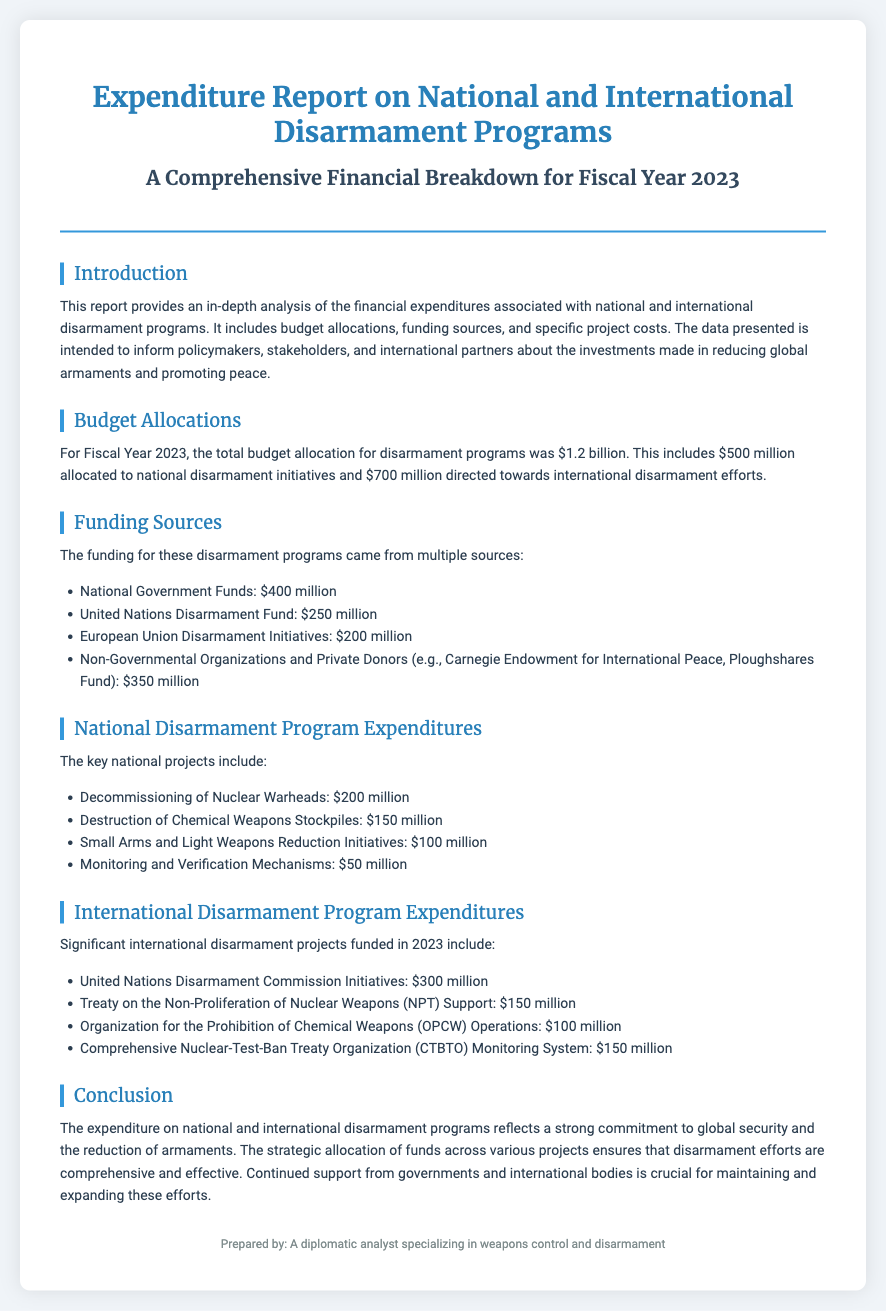What is the total budget allocation for disarmament programs? The total budget allocation for Fiscal Year 2023 is explicitly stated in the document as $1.2 billion.
Answer: $1.2 billion How much was allocated to national disarmament initiatives? The document specifies that $500 million was allocated to national disarmament initiatives.
Answer: $500 million What is one source of funding mentioned in the document? The document lists multiple funding sources, one of which is the National Government Funds.
Answer: National Government Funds What is the expenditure for the destruction of chemical weapons stockpiles? The specific project cost for the destruction of chemical weapons stockpiles is provided in the document as $150 million.
Answer: $150 million How much is allocated to the United Nations Disarmament Commission Initiatives? The expenditure for the United Nations Disarmament Commission Initiatives is detailed in the document as $300 million.
Answer: $300 million Which international treaty received $150 million for support? The document mentions that the Treaty on the Non-Proliferation of Nuclear Weapons received $150 million for support.
Answer: Treaty on the Non-Proliferation of Nuclear Weapons What is the focus of the expenditure report? The primary focus of the expenditure report is the financial expenditures associated with disarmament programs.
Answer: Financial expenditures associated with disarmament programs How much was spent on monitoring and verification mechanisms? The document states that $50 million was spent on monitoring and verification mechanisms in the national disarmament program.
Answer: $50 million What does the conclusion emphasize about the funding? The conclusion emphasizes the importance of continued support from governments and international bodies for maintaining disarmament efforts.
Answer: Continued support from governments and international bodies 